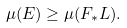Convert formula to latex. <formula><loc_0><loc_0><loc_500><loc_500>\mu ( E ) \geq \mu ( F _ { * } L ) .</formula> 